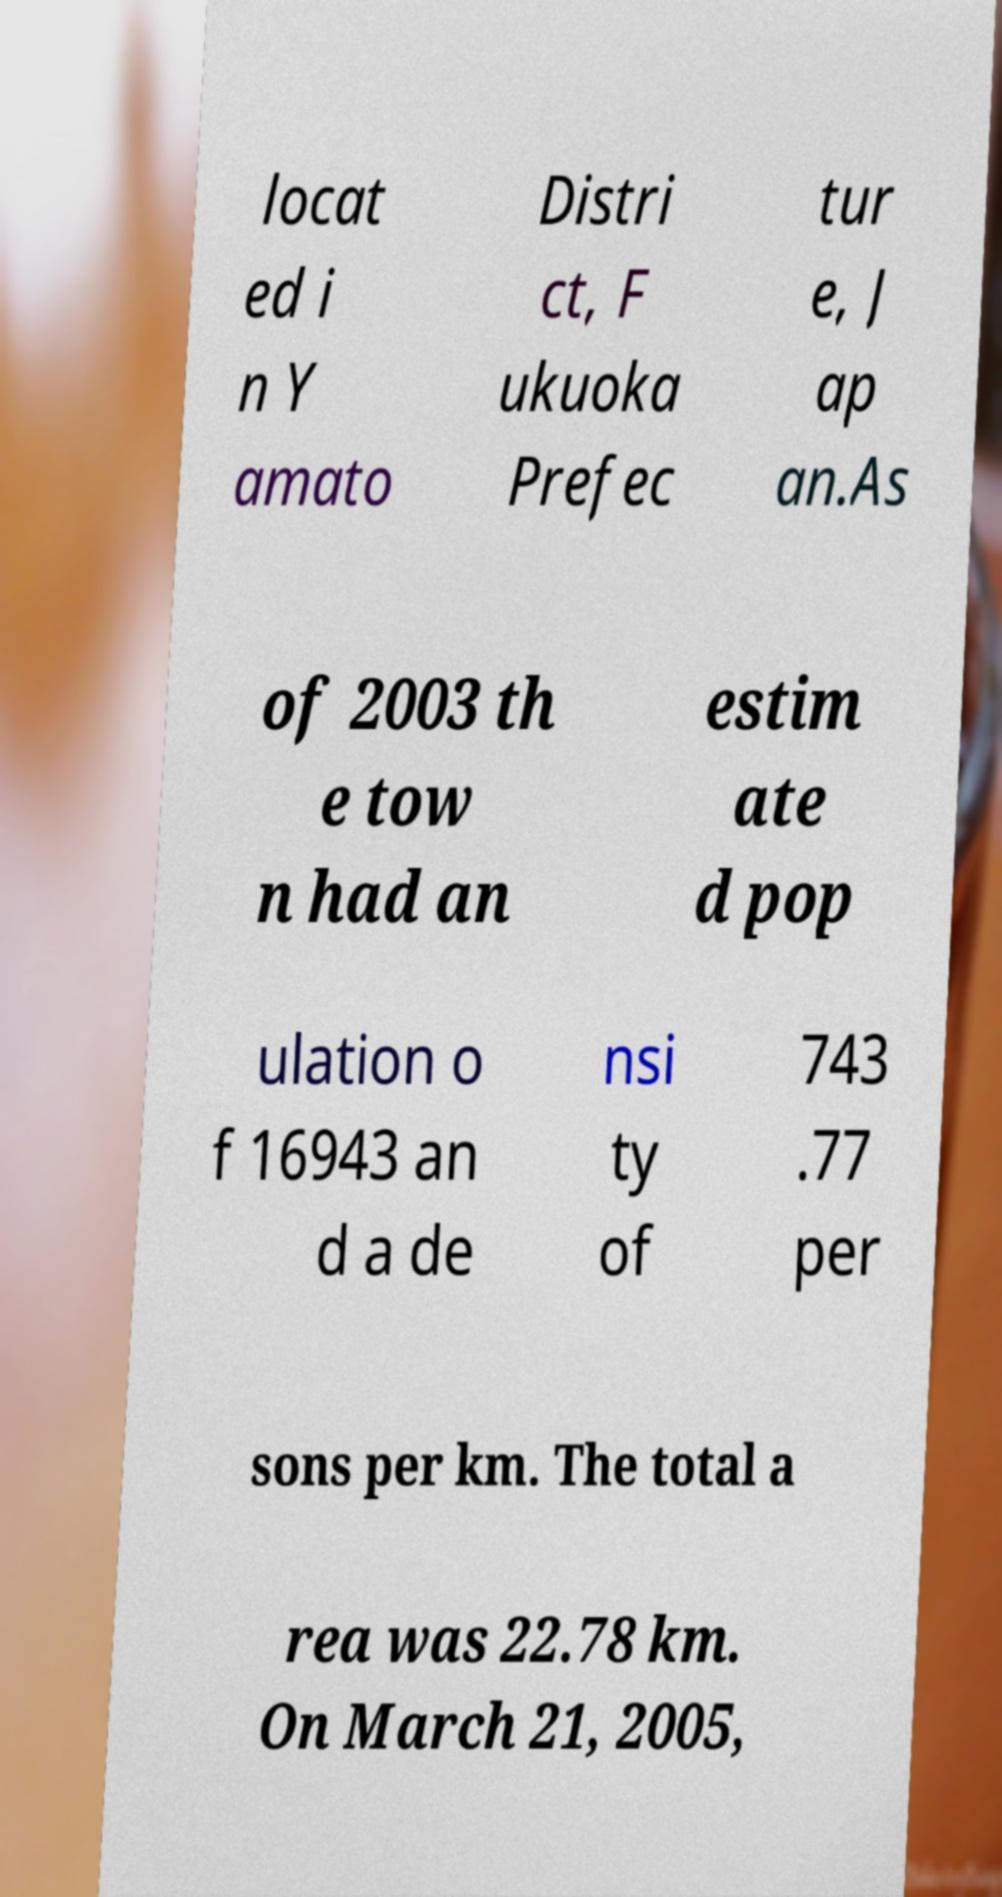Could you assist in decoding the text presented in this image and type it out clearly? locat ed i n Y amato Distri ct, F ukuoka Prefec tur e, J ap an.As of 2003 th e tow n had an estim ate d pop ulation o f 16943 an d a de nsi ty of 743 .77 per sons per km. The total a rea was 22.78 km. On March 21, 2005, 